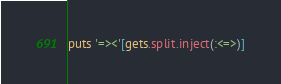<code> <loc_0><loc_0><loc_500><loc_500><_Ruby_>puts '=><'[gets.split.inject(:<=>)]</code> 